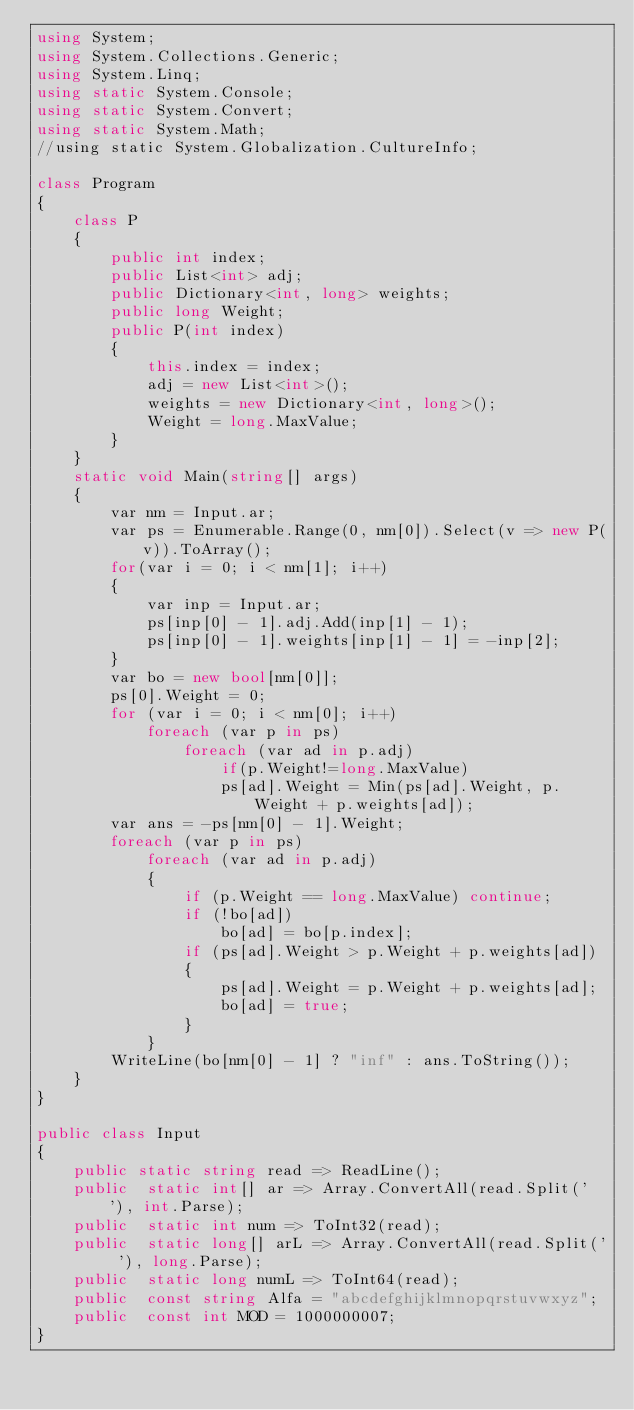<code> <loc_0><loc_0><loc_500><loc_500><_C#_>using System;
using System.Collections.Generic;
using System.Linq;
using static System.Console;
using static System.Convert;
using static System.Math;
//using static System.Globalization.CultureInfo;

class Program
{
    class P
    {
        public int index;
        public List<int> adj;
        public Dictionary<int, long> weights;
        public long Weight;
        public P(int index)
        {
            this.index = index;
            adj = new List<int>();
            weights = new Dictionary<int, long>();
            Weight = long.MaxValue;
        }
    }
    static void Main(string[] args)
    {
        var nm = Input.ar;
        var ps = Enumerable.Range(0, nm[0]).Select(v => new P(v)).ToArray();
        for(var i = 0; i < nm[1]; i++)
        {
            var inp = Input.ar;
            ps[inp[0] - 1].adj.Add(inp[1] - 1);
            ps[inp[0] - 1].weights[inp[1] - 1] = -inp[2];
        }
        var bo = new bool[nm[0]];
        ps[0].Weight = 0;
        for (var i = 0; i < nm[0]; i++)
            foreach (var p in ps)
                foreach (var ad in p.adj)
                    if(p.Weight!=long.MaxValue)
                    ps[ad].Weight = Min(ps[ad].Weight, p.Weight + p.weights[ad]);
        var ans = -ps[nm[0] - 1].Weight;
        foreach (var p in ps)
            foreach (var ad in p.adj)
            {
                if (p.Weight == long.MaxValue) continue;
                if (!bo[ad])
                    bo[ad] = bo[p.index];
                if (ps[ad].Weight > p.Weight + p.weights[ad])
                {
                    ps[ad].Weight = p.Weight + p.weights[ad];
                    bo[ad] = true;
                }
            }
        WriteLine(bo[nm[0] - 1] ? "inf" : ans.ToString());
    }
}

public class Input
{
    public static string read => ReadLine();
    public  static int[] ar => Array.ConvertAll(read.Split(' '), int.Parse);
    public  static int num => ToInt32(read);
    public  static long[] arL => Array.ConvertAll(read.Split(' '), long.Parse);
    public  static long numL => ToInt64(read);
    public  const string Alfa = "abcdefghijklmnopqrstuvwxyz";
    public  const int MOD = 1000000007;
}
</code> 